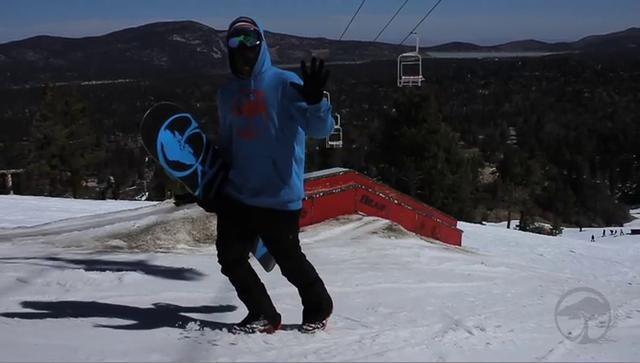Describe the objects in this image and their specific colors. I can see people in blue, black, navy, and darkgray tones, snowboard in blue, black, and navy tones, people in blue, darkgray, gray, and black tones, people in blue, black, gray, and darkgray tones, and people in black and blue tones in this image. 